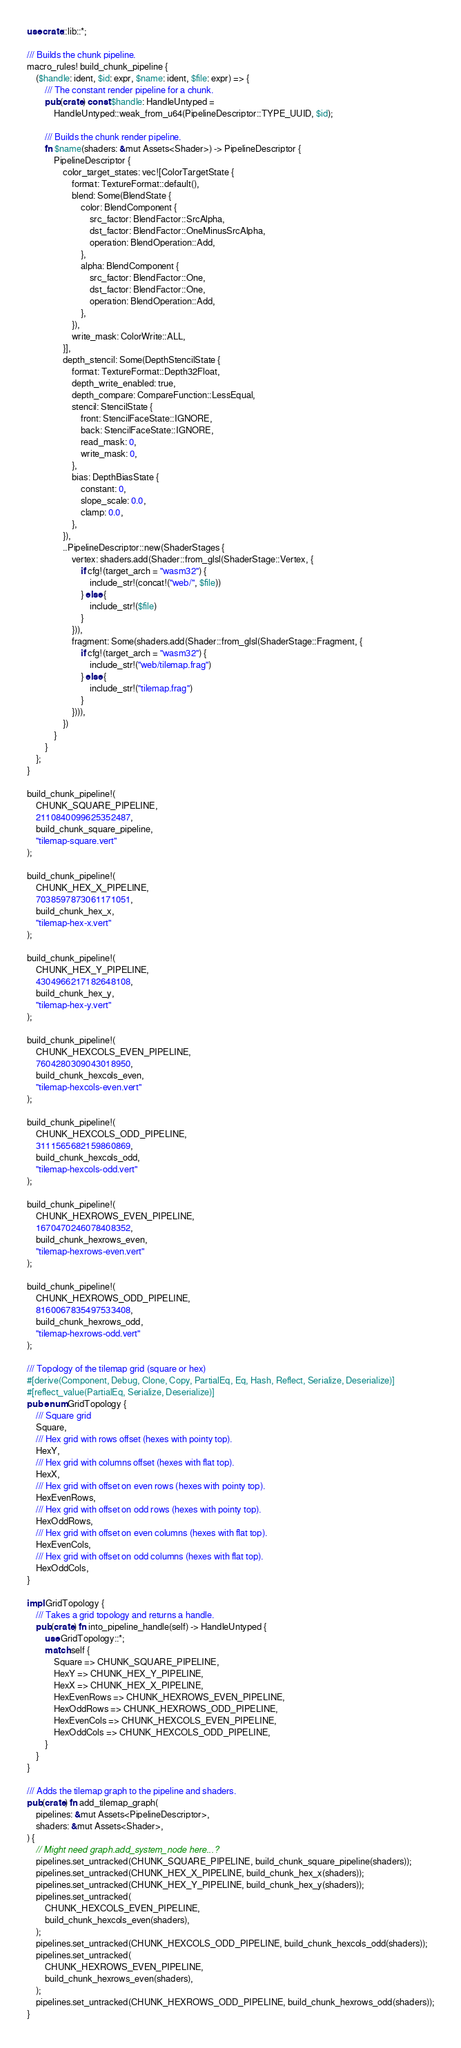<code> <loc_0><loc_0><loc_500><loc_500><_Rust_>use crate::lib::*;

/// Builds the chunk pipeline.
macro_rules! build_chunk_pipeline {
    ($handle: ident, $id: expr, $name: ident, $file: expr) => {
        /// The constant render pipeline for a chunk.
        pub(crate) const $handle: HandleUntyped =
            HandleUntyped::weak_from_u64(PipelineDescriptor::TYPE_UUID, $id);

        /// Builds the chunk render pipeline.
        fn $name(shaders: &mut Assets<Shader>) -> PipelineDescriptor {
            PipelineDescriptor {
                color_target_states: vec![ColorTargetState {
                    format: TextureFormat::default(),
                    blend: Some(BlendState {
                        color: BlendComponent {
                            src_factor: BlendFactor::SrcAlpha,
                            dst_factor: BlendFactor::OneMinusSrcAlpha,
                            operation: BlendOperation::Add,
                        },
                        alpha: BlendComponent {
                            src_factor: BlendFactor::One,
                            dst_factor: BlendFactor::One,
                            operation: BlendOperation::Add,
                        },
                    }),
                    write_mask: ColorWrite::ALL,
                }],
                depth_stencil: Some(DepthStencilState {
                    format: TextureFormat::Depth32Float,
                    depth_write_enabled: true,
                    depth_compare: CompareFunction::LessEqual,
                    stencil: StencilState {
                        front: StencilFaceState::IGNORE,
                        back: StencilFaceState::IGNORE,
                        read_mask: 0,
                        write_mask: 0,
                    },
                    bias: DepthBiasState {
                        constant: 0,
                        slope_scale: 0.0,
                        clamp: 0.0,
                    },
                }),
                ..PipelineDescriptor::new(ShaderStages {
                    vertex: shaders.add(Shader::from_glsl(ShaderStage::Vertex, {
                        if cfg!(target_arch = "wasm32") {
                            include_str!(concat!("web/", $file))
                        } else {
                            include_str!($file)
                        }
                    })),
                    fragment: Some(shaders.add(Shader::from_glsl(ShaderStage::Fragment, {
                        if cfg!(target_arch = "wasm32") {
                            include_str!("web/tilemap.frag")
                        } else {
                            include_str!("tilemap.frag")
                        }
                    }))),
                })
            }
        }
    };
}

build_chunk_pipeline!(
    CHUNK_SQUARE_PIPELINE,
    2110840099625352487,
    build_chunk_square_pipeline,
    "tilemap-square.vert"
);

build_chunk_pipeline!(
    CHUNK_HEX_X_PIPELINE,
    7038597873061171051,
    build_chunk_hex_x,
    "tilemap-hex-x.vert"
);

build_chunk_pipeline!(
    CHUNK_HEX_Y_PIPELINE,
    4304966217182648108,
    build_chunk_hex_y,
    "tilemap-hex-y.vert"
);

build_chunk_pipeline!(
    CHUNK_HEXCOLS_EVEN_PIPELINE,
    7604280309043018950,
    build_chunk_hexcols_even,
    "tilemap-hexcols-even.vert"
);

build_chunk_pipeline!(
    CHUNK_HEXCOLS_ODD_PIPELINE,
    3111565682159860869,
    build_chunk_hexcols_odd,
    "tilemap-hexcols-odd.vert"
);

build_chunk_pipeline!(
    CHUNK_HEXROWS_EVEN_PIPELINE,
    1670470246078408352,
    build_chunk_hexrows_even,
    "tilemap-hexrows-even.vert"
);

build_chunk_pipeline!(
    CHUNK_HEXROWS_ODD_PIPELINE,
    8160067835497533408,
    build_chunk_hexrows_odd,
    "tilemap-hexrows-odd.vert"
);

/// Topology of the tilemap grid (square or hex)
#[derive(Component, Debug, Clone, Copy, PartialEq, Eq, Hash, Reflect, Serialize, Deserialize)]
#[reflect_value(PartialEq, Serialize, Deserialize)]
pub enum GridTopology {
    /// Square grid
    Square,
    /// Hex grid with rows offset (hexes with pointy top).
    HexY,
    /// Hex grid with columns offset (hexes with flat top).
    HexX,
    /// Hex grid with offset on even rows (hexes with pointy top).
    HexEvenRows,
    /// Hex grid with offset on odd rows (hexes with pointy top).
    HexOddRows,
    /// Hex grid with offset on even columns (hexes with flat top).
    HexEvenCols,
    /// Hex grid with offset on odd columns (hexes with flat top).
    HexOddCols,
}

impl GridTopology {
    /// Takes a grid topology and returns a handle.
    pub(crate) fn into_pipeline_handle(self) -> HandleUntyped {
        use GridTopology::*;
        match self {
            Square => CHUNK_SQUARE_PIPELINE,
            HexY => CHUNK_HEX_Y_PIPELINE,
            HexX => CHUNK_HEX_X_PIPELINE,
            HexEvenRows => CHUNK_HEXROWS_EVEN_PIPELINE,
            HexOddRows => CHUNK_HEXROWS_ODD_PIPELINE,
            HexEvenCols => CHUNK_HEXCOLS_EVEN_PIPELINE,
            HexOddCols => CHUNK_HEXCOLS_ODD_PIPELINE,
        }
    }
}

/// Adds the tilemap graph to the pipeline and shaders.
pub(crate) fn add_tilemap_graph(
    pipelines: &mut Assets<PipelineDescriptor>,
    shaders: &mut Assets<Shader>,
) {
    // Might need graph.add_system_node here...?
    pipelines.set_untracked(CHUNK_SQUARE_PIPELINE, build_chunk_square_pipeline(shaders));
    pipelines.set_untracked(CHUNK_HEX_X_PIPELINE, build_chunk_hex_x(shaders));
    pipelines.set_untracked(CHUNK_HEX_Y_PIPELINE, build_chunk_hex_y(shaders));
    pipelines.set_untracked(
        CHUNK_HEXCOLS_EVEN_PIPELINE,
        build_chunk_hexcols_even(shaders),
    );
    pipelines.set_untracked(CHUNK_HEXCOLS_ODD_PIPELINE, build_chunk_hexcols_odd(shaders));
    pipelines.set_untracked(
        CHUNK_HEXROWS_EVEN_PIPELINE,
        build_chunk_hexrows_even(shaders),
    );
    pipelines.set_untracked(CHUNK_HEXROWS_ODD_PIPELINE, build_chunk_hexrows_odd(shaders));
}
</code> 